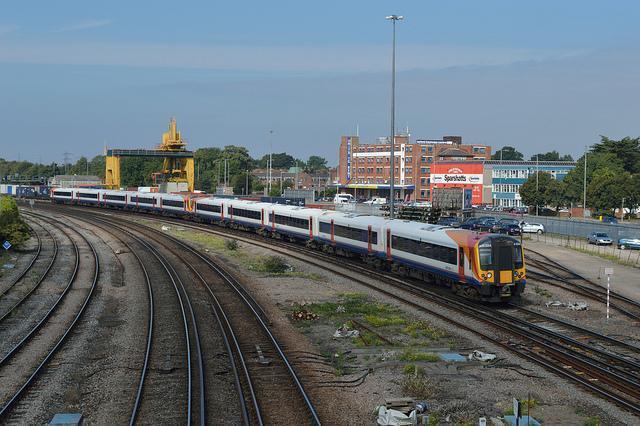How many carrots are in the dish?
Give a very brief answer. 0. 